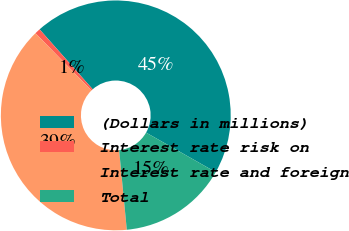Convert chart. <chart><loc_0><loc_0><loc_500><loc_500><pie_chart><fcel>(Dollars in millions)<fcel>Interest rate risk on<fcel>Interest rate and foreign<fcel>Total<nl><fcel>44.76%<fcel>0.78%<fcel>39.21%<fcel>15.25%<nl></chart> 